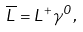Convert formula to latex. <formula><loc_0><loc_0><loc_500><loc_500>\overline { L } = L ^ { + } \gamma ^ { 0 } ,</formula> 